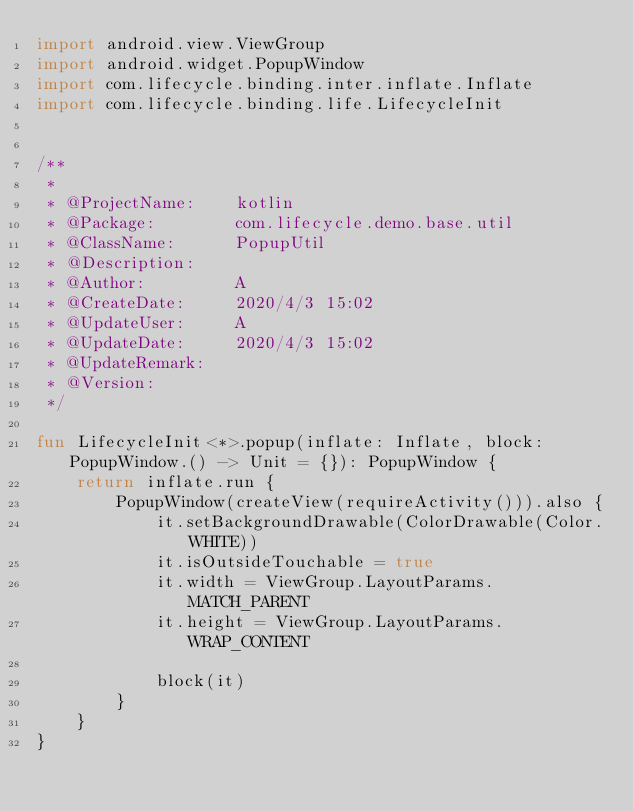Convert code to text. <code><loc_0><loc_0><loc_500><loc_500><_Kotlin_>import android.view.ViewGroup
import android.widget.PopupWindow
import com.lifecycle.binding.inter.inflate.Inflate
import com.lifecycle.binding.life.LifecycleInit


/**
 *
 * @ProjectName:    kotlin
 * @Package:        com.lifecycle.demo.base.util
 * @ClassName:      PopupUtil
 * @Description:
 * @Author:         A
 * @CreateDate:     2020/4/3 15:02
 * @UpdateUser:     A
 * @UpdateDate:     2020/4/3 15:02
 * @UpdateRemark:
 * @Version:
 */

fun LifecycleInit<*>.popup(inflate: Inflate, block: PopupWindow.() -> Unit = {}): PopupWindow {
    return inflate.run {
        PopupWindow(createView(requireActivity())).also {
            it.setBackgroundDrawable(ColorDrawable(Color.WHITE))
            it.isOutsideTouchable = true
            it.width = ViewGroup.LayoutParams.MATCH_PARENT
            it.height = ViewGroup.LayoutParams.WRAP_CONTENT

            block(it)
        }
    }
}
</code> 